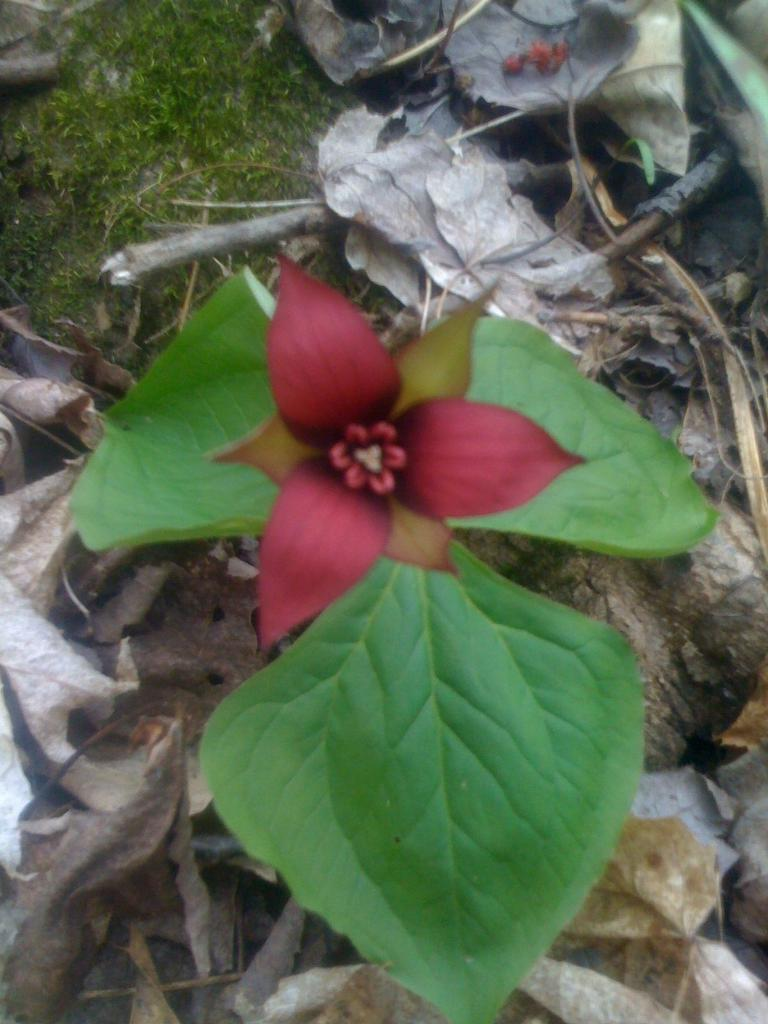What is the main subject of the image? There is a flower in the image. Can you describe the colors of the flower? The flower has pink, brown, and green colors. What is the flower attached to? The flower is attached to a green plant. What other elements can be seen in the image? There are dried leaves and grass on the ground in the image. What type of coal is visible in the image? There is no coal present in the image. Is the flower wearing a vest in the image? The flower is not a living being and therefore cannot wear a vest. 